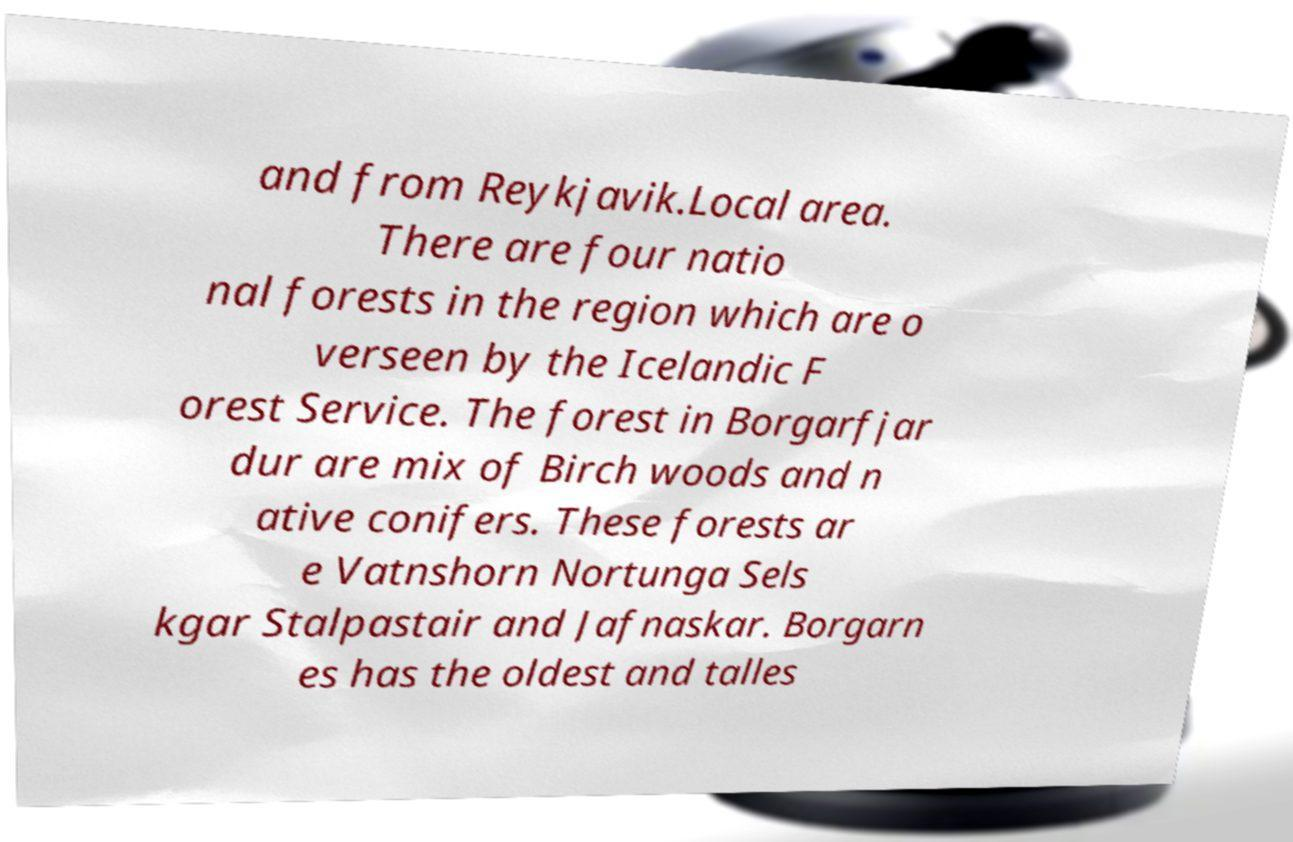Could you extract and type out the text from this image? and from Reykjavik.Local area. There are four natio nal forests in the region which are o verseen by the Icelandic F orest Service. The forest in Borgarfjar dur are mix of Birch woods and n ative conifers. These forests ar e Vatnshorn Nortunga Sels kgar Stalpastair and Jafnaskar. Borgarn es has the oldest and talles 